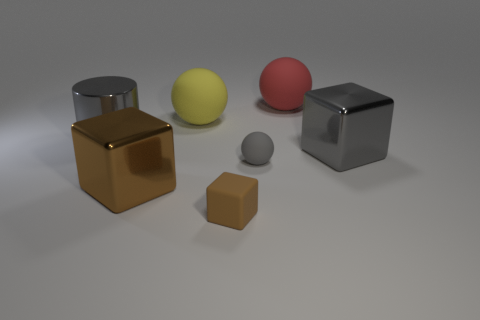Are there any small brown rubber blocks in front of the big gray metal cylinder?
Your response must be concise. Yes. What shape is the tiny brown object?
Your answer should be compact. Cube. The rubber object that is in front of the shiny cube to the left of the big ball that is on the right side of the tiny gray matte object is what shape?
Your answer should be very brief. Cube. What material is the big block in front of the gray thing that is on the right side of the big red sphere?
Your response must be concise. Metal. Is there anything else that has the same size as the rubber cube?
Offer a terse response. Yes. Does the big yellow sphere have the same material as the big gray object that is in front of the big gray metallic cylinder?
Your answer should be very brief. No. What is the big object that is left of the big yellow object and right of the large shiny cylinder made of?
Your answer should be compact. Metal. What is the color of the block to the right of the brown block in front of the brown metal object?
Give a very brief answer. Gray. What material is the tiny thing that is behind the big brown metallic block?
Your response must be concise. Rubber. Is the number of big shiny cubes less than the number of tiny gray spheres?
Give a very brief answer. No. 